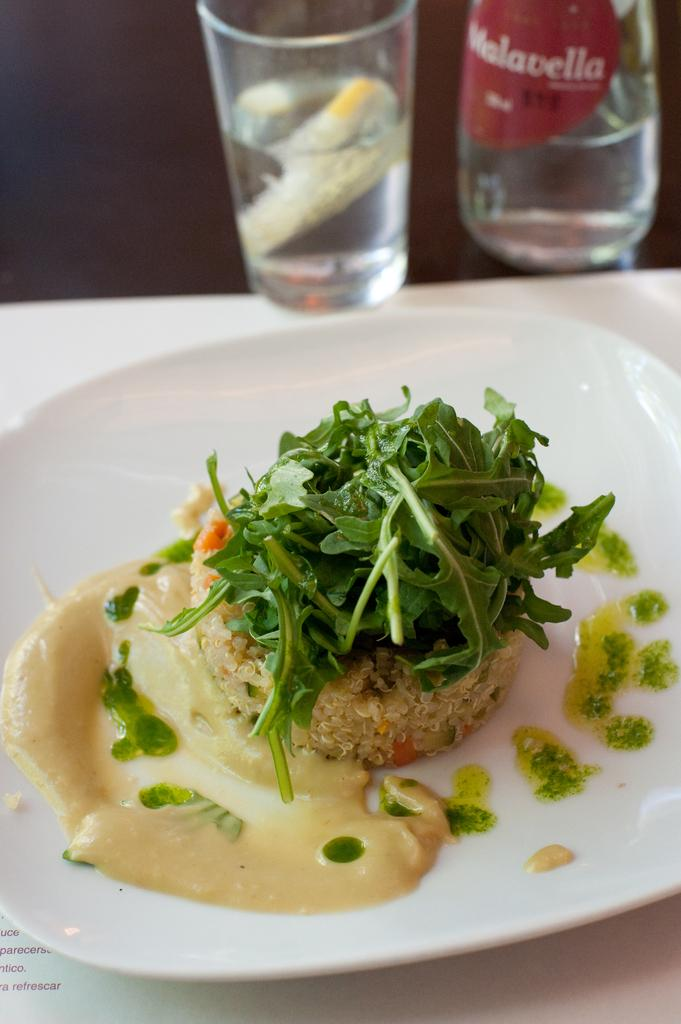<image>
Give a short and clear explanation of the subsequent image. A restaurant table with a meal and a glass that says Malavella. 